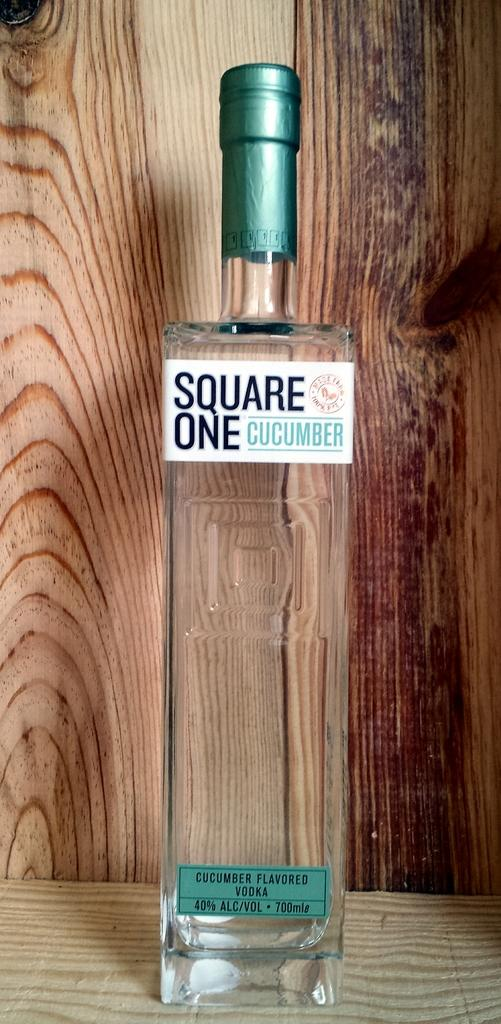<image>
Summarize the visual content of the image. A rectangle bottle of cucumber vodka standing in a wooden presentation box. 